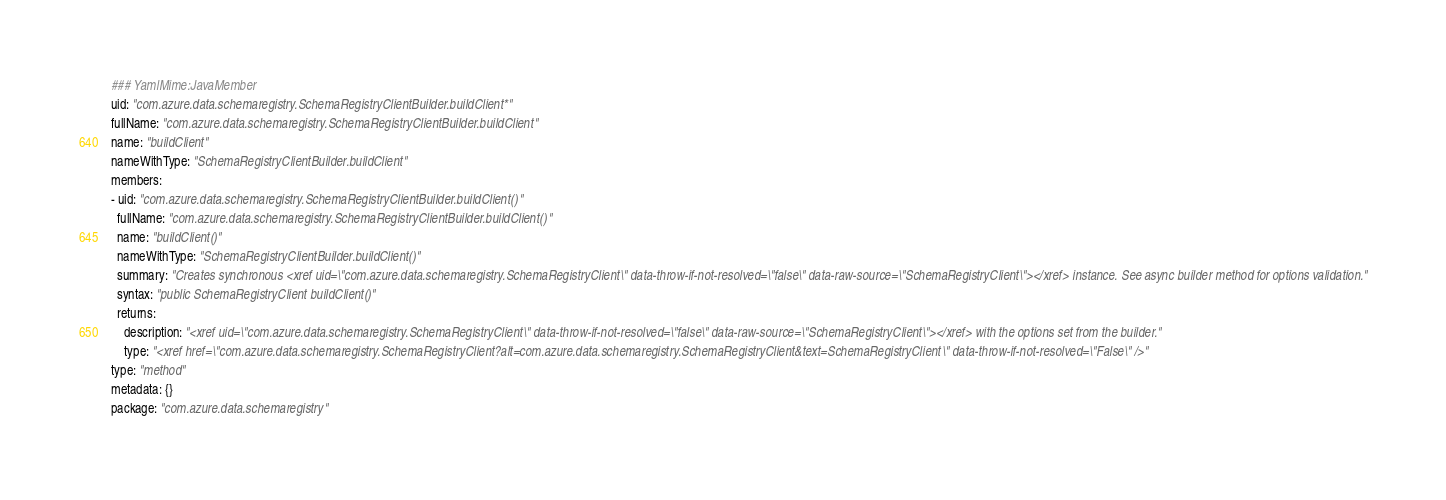<code> <loc_0><loc_0><loc_500><loc_500><_YAML_>### YamlMime:JavaMember
uid: "com.azure.data.schemaregistry.SchemaRegistryClientBuilder.buildClient*"
fullName: "com.azure.data.schemaregistry.SchemaRegistryClientBuilder.buildClient"
name: "buildClient"
nameWithType: "SchemaRegistryClientBuilder.buildClient"
members:
- uid: "com.azure.data.schemaregistry.SchemaRegistryClientBuilder.buildClient()"
  fullName: "com.azure.data.schemaregistry.SchemaRegistryClientBuilder.buildClient()"
  name: "buildClient()"
  nameWithType: "SchemaRegistryClientBuilder.buildClient()"
  summary: "Creates synchronous <xref uid=\"com.azure.data.schemaregistry.SchemaRegistryClient\" data-throw-if-not-resolved=\"false\" data-raw-source=\"SchemaRegistryClient\"></xref> instance. See async builder method for options validation."
  syntax: "public SchemaRegistryClient buildClient()"
  returns:
    description: "<xref uid=\"com.azure.data.schemaregistry.SchemaRegistryClient\" data-throw-if-not-resolved=\"false\" data-raw-source=\"SchemaRegistryClient\"></xref> with the options set from the builder."
    type: "<xref href=\"com.azure.data.schemaregistry.SchemaRegistryClient?alt=com.azure.data.schemaregistry.SchemaRegistryClient&text=SchemaRegistryClient\" data-throw-if-not-resolved=\"False\" />"
type: "method"
metadata: {}
package: "com.azure.data.schemaregistry"</code> 